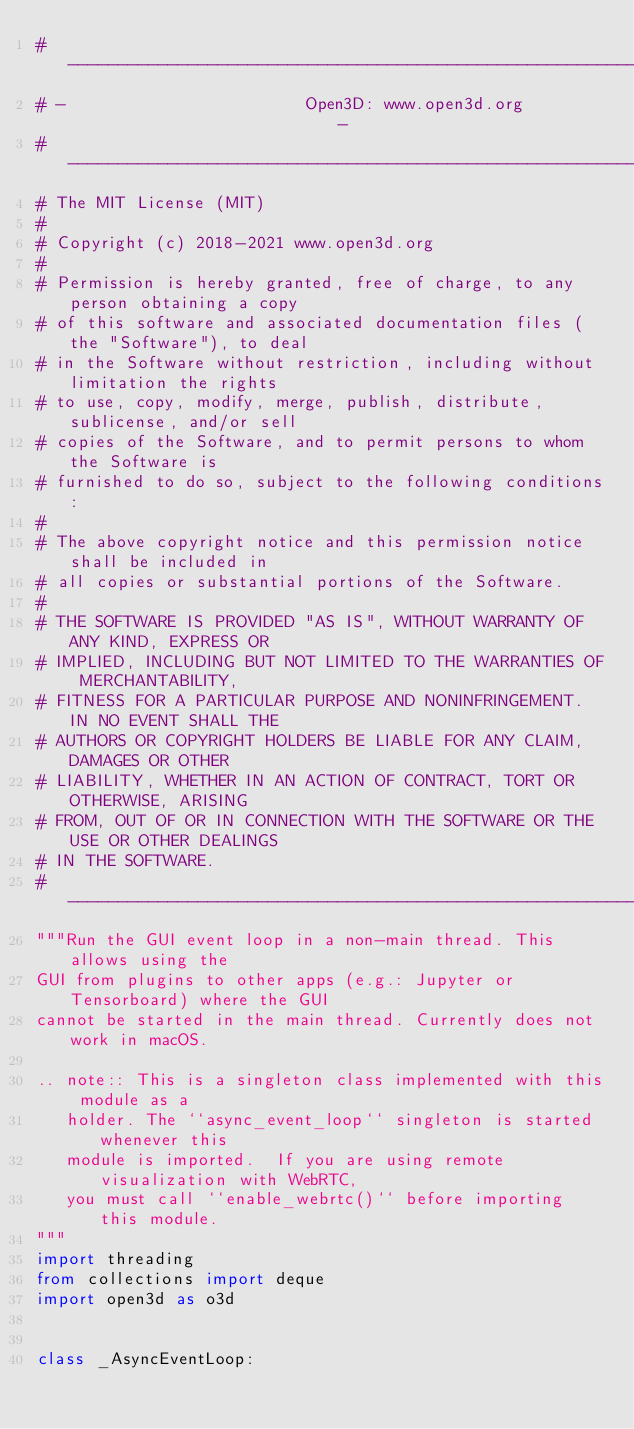<code> <loc_0><loc_0><loc_500><loc_500><_Python_># ----------------------------------------------------------------------------
# -                        Open3D: www.open3d.org                            -
# ----------------------------------------------------------------------------
# The MIT License (MIT)
#
# Copyright (c) 2018-2021 www.open3d.org
#
# Permission is hereby granted, free of charge, to any person obtaining a copy
# of this software and associated documentation files (the "Software"), to deal
# in the Software without restriction, including without limitation the rights
# to use, copy, modify, merge, publish, distribute, sublicense, and/or sell
# copies of the Software, and to permit persons to whom the Software is
# furnished to do so, subject to the following conditions:
#
# The above copyright notice and this permission notice shall be included in
# all copies or substantial portions of the Software.
#
# THE SOFTWARE IS PROVIDED "AS IS", WITHOUT WARRANTY OF ANY KIND, EXPRESS OR
# IMPLIED, INCLUDING BUT NOT LIMITED TO THE WARRANTIES OF MERCHANTABILITY,
# FITNESS FOR A PARTICULAR PURPOSE AND NONINFRINGEMENT. IN NO EVENT SHALL THE
# AUTHORS OR COPYRIGHT HOLDERS BE LIABLE FOR ANY CLAIM, DAMAGES OR OTHER
# LIABILITY, WHETHER IN AN ACTION OF CONTRACT, TORT OR OTHERWISE, ARISING
# FROM, OUT OF OR IN CONNECTION WITH THE SOFTWARE OR THE USE OR OTHER DEALINGS
# IN THE SOFTWARE.
# ----------------------------------------------------------------------------
"""Run the GUI event loop in a non-main thread. This allows using the
GUI from plugins to other apps (e.g.: Jupyter or Tensorboard) where the GUI
cannot be started in the main thread. Currently does not work in macOS.

.. note:: This is a singleton class implemented with this module as a
   holder. The ``async_event_loop`` singleton is started whenever this
   module is imported.  If you are using remote visualization with WebRTC,
   you must call ``enable_webrtc()`` before importing this module.
"""
import threading
from collections import deque
import open3d as o3d


class _AsyncEventLoop:
</code> 